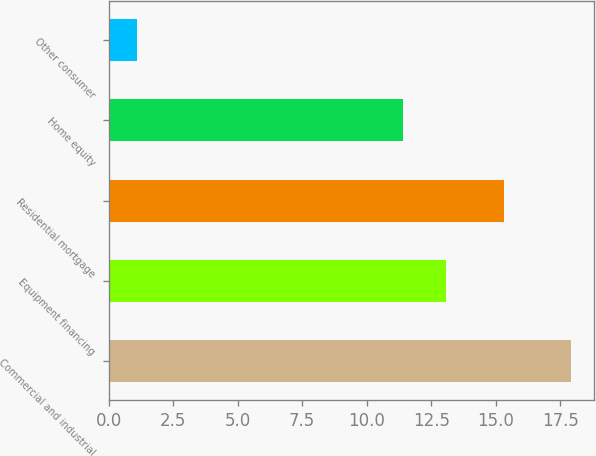Convert chart to OTSL. <chart><loc_0><loc_0><loc_500><loc_500><bar_chart><fcel>Commercial and industrial<fcel>Equipment financing<fcel>Residential mortgage<fcel>Home equity<fcel>Other consumer<nl><fcel>17.9<fcel>13.08<fcel>15.3<fcel>11.4<fcel>1.1<nl></chart> 